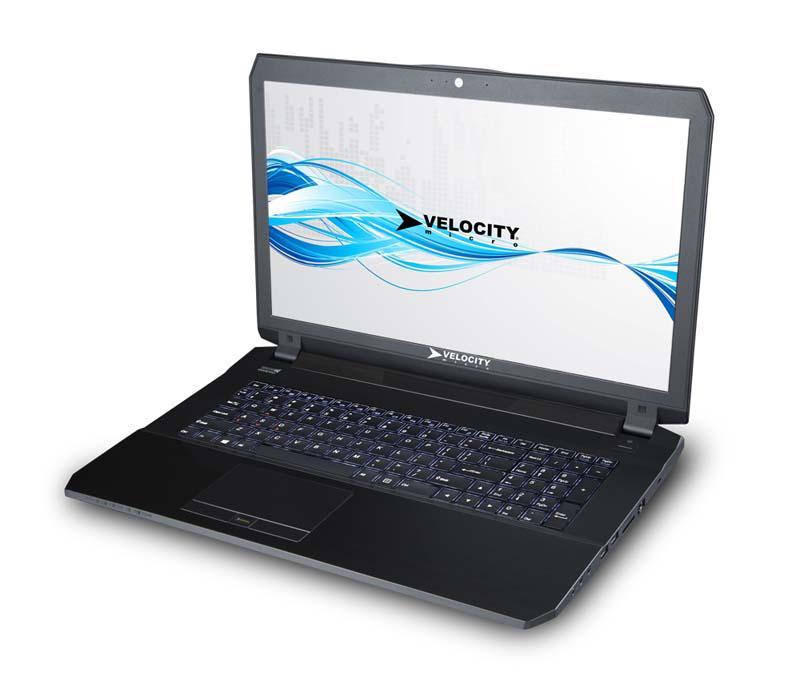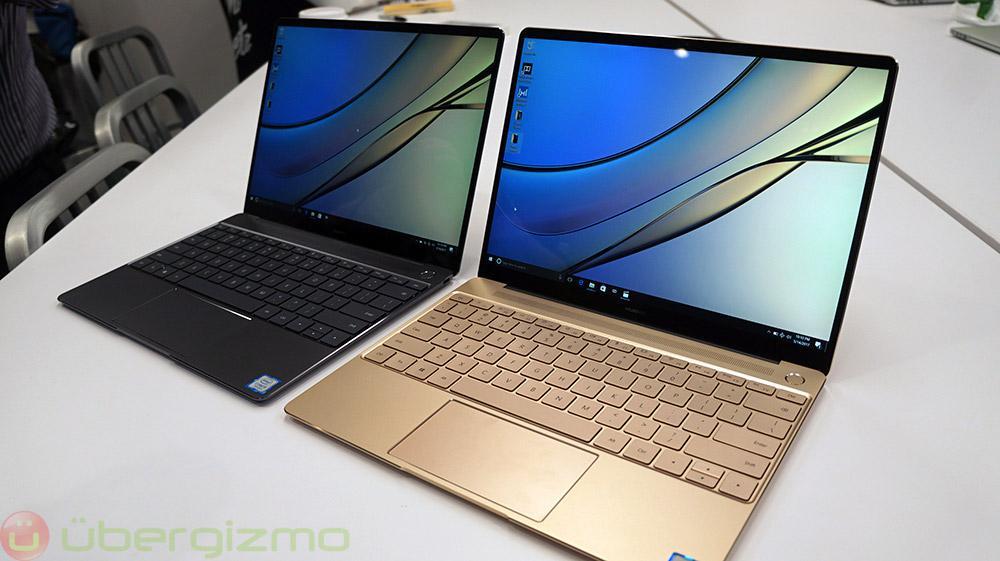The first image is the image on the left, the second image is the image on the right. For the images shown, is this caption "One image shows side-by-side open laptops and the other shows a single open laptop, and all laptops are angled somewhat leftward and display curving lines on the screen." true? Answer yes or no. Yes. The first image is the image on the left, the second image is the image on the right. Analyze the images presented: Is the assertion "All the desktops have the same design." valid? Answer yes or no. No. 